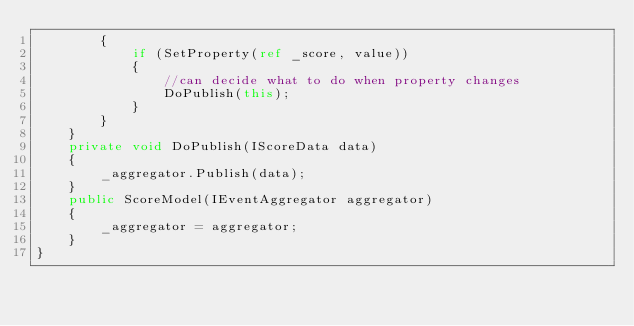<code> <loc_0><loc_0><loc_500><loc_500><_C#_>        {
            if (SetProperty(ref _score, value))
            {
                //can decide what to do when property changes
                DoPublish(this);
            }
        }
    }
    private void DoPublish(IScoreData data)
    {
        _aggregator.Publish(data);
    }
    public ScoreModel(IEventAggregator aggregator)
    {
        _aggregator = aggregator;
    }
}</code> 